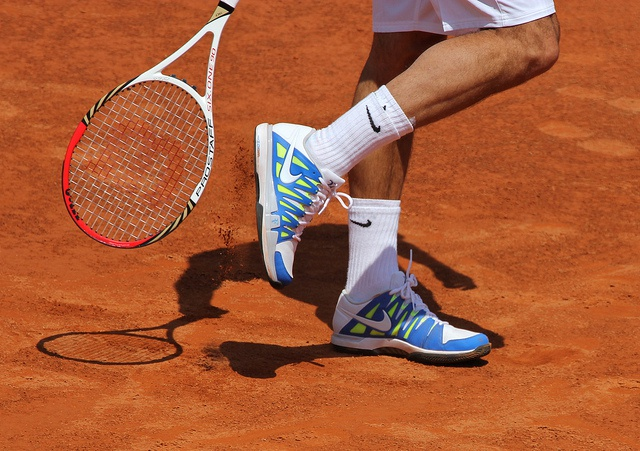Describe the objects in this image and their specific colors. I can see people in brown, lavender, maroon, and black tones and tennis racket in brown and lightgray tones in this image. 